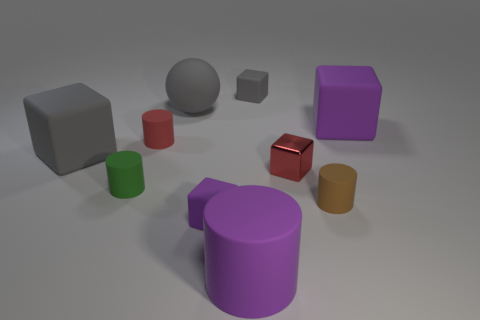How many other things are the same color as the small metal block?
Provide a succinct answer. 1. What number of matte objects are either big purple blocks or tiny things?
Keep it short and to the point. 6. Are there any other things that are made of the same material as the red cube?
Give a very brief answer. No. There is a large ball; is its color the same as the small cylinder right of the tiny gray matte cube?
Ensure brevity in your answer.  No. The tiny red rubber thing is what shape?
Give a very brief answer. Cylinder. There is a matte cylinder to the right of the red object on the right side of the purple block to the left of the brown cylinder; what size is it?
Make the answer very short. Small. What number of other things are the same shape as the small purple rubber object?
Make the answer very short. 4. Does the object left of the small green cylinder have the same shape as the big purple rubber thing that is to the right of the small red metallic thing?
Keep it short and to the point. Yes. How many balls are either tiny red objects or tiny red rubber objects?
Your response must be concise. 0. The small thing that is behind the purple matte cube that is behind the small cylinder that is behind the metal object is made of what material?
Offer a terse response. Rubber. 